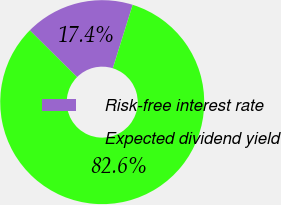<chart> <loc_0><loc_0><loc_500><loc_500><pie_chart><fcel>Risk-free interest rate<fcel>Expected dividend yield<nl><fcel>17.39%<fcel>82.61%<nl></chart> 